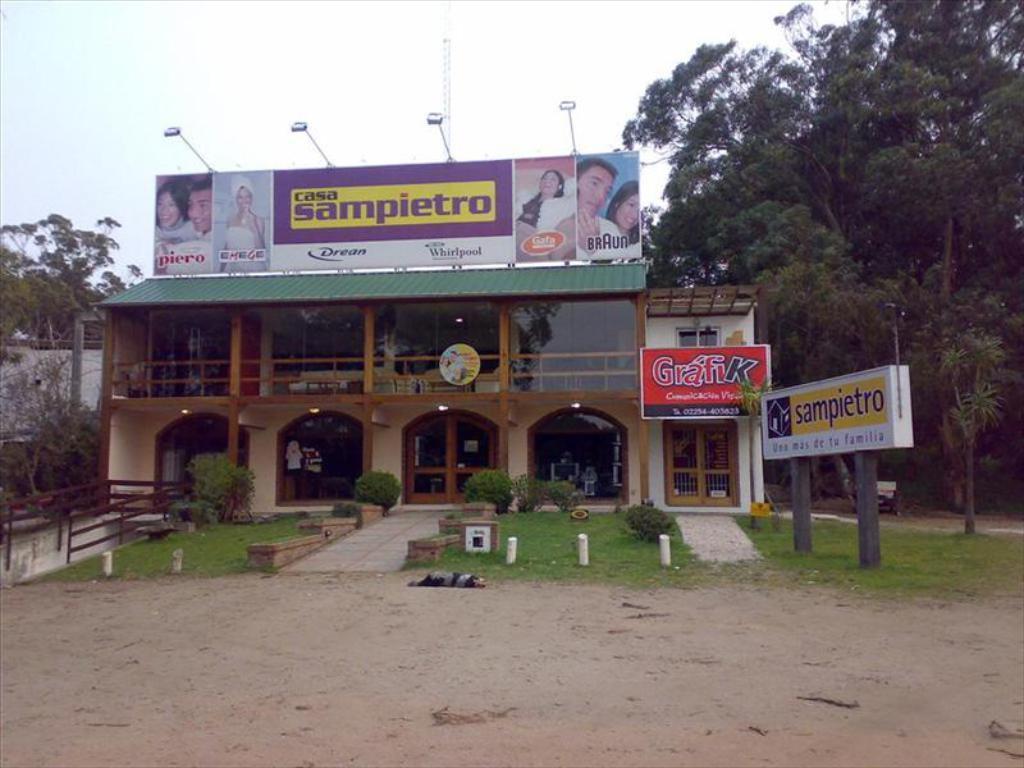Can you describe this image briefly? In this image there is a building in the middle. In front of the building there is a garden in which there are small plants. At the top there is a hoarding. On the right side there are trees. At the top there is the sky. On the right side there is a boarding on the ground. 